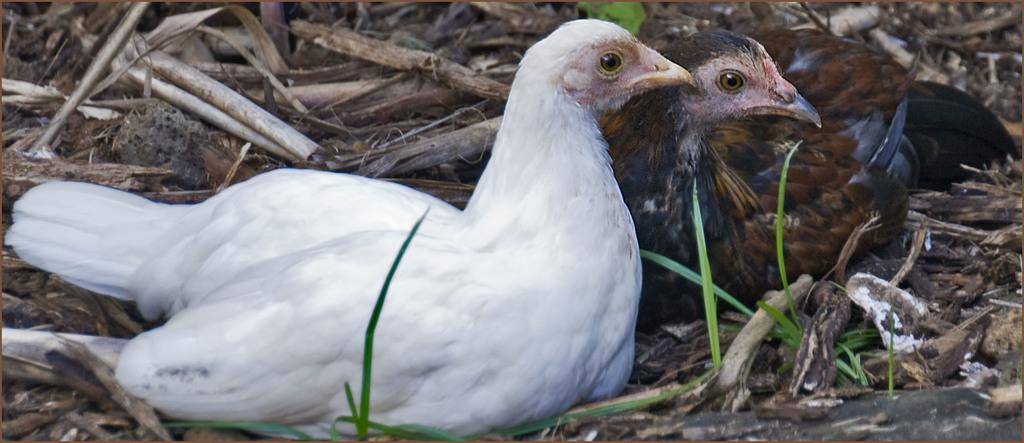How many birds are present in the image? There are two birds in the image. What are the birds doing in the image? The birds are sitting. What can be seen at the bottom of the image? There are sticks and plants at the bottom of the image. What colors are the birds in the image? One bird is white in color, and the other bird is brown in color. What shape is the grain in the image? There is no grain present in the image. 